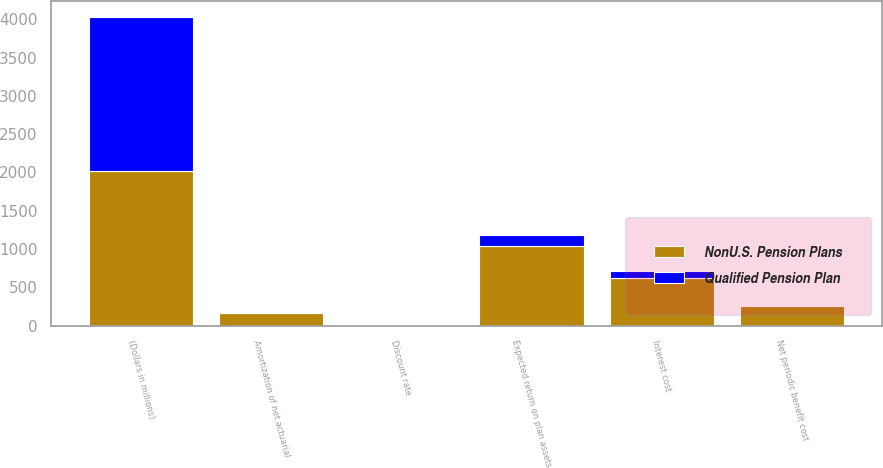Convert chart to OTSL. <chart><loc_0><loc_0><loc_500><loc_500><stacked_bar_chart><ecel><fcel>(Dollars in millions)<fcel>Interest cost<fcel>Expected return on plan assets<fcel>Amortization of net actuarial<fcel>Net periodic benefit cost<fcel>Discount rate<nl><fcel>NonU.S. Pension Plans<fcel>2015<fcel>621<fcel>1045<fcel>170<fcel>254<fcel>4.12<nl><fcel>Qualified Pension Plan<fcel>2015<fcel>93<fcel>133<fcel>6<fcel>6<fcel>3.56<nl></chart> 